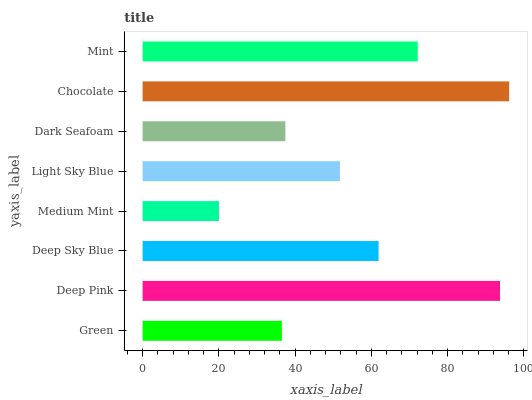Is Medium Mint the minimum?
Answer yes or no. Yes. Is Chocolate the maximum?
Answer yes or no. Yes. Is Deep Pink the minimum?
Answer yes or no. No. Is Deep Pink the maximum?
Answer yes or no. No. Is Deep Pink greater than Green?
Answer yes or no. Yes. Is Green less than Deep Pink?
Answer yes or no. Yes. Is Green greater than Deep Pink?
Answer yes or no. No. Is Deep Pink less than Green?
Answer yes or no. No. Is Deep Sky Blue the high median?
Answer yes or no. Yes. Is Light Sky Blue the low median?
Answer yes or no. Yes. Is Dark Seafoam the high median?
Answer yes or no. No. Is Deep Pink the low median?
Answer yes or no. No. 